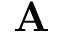<formula> <loc_0><loc_0><loc_500><loc_500>\mathbf A</formula> 